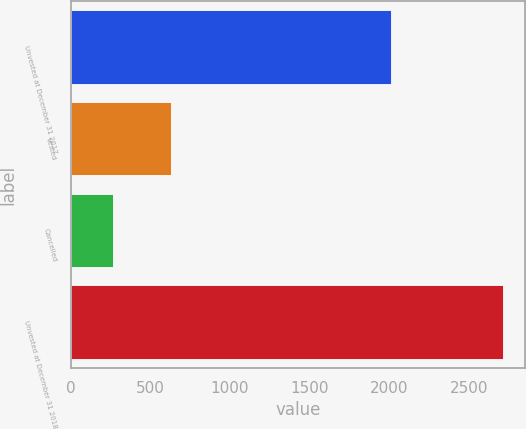<chart> <loc_0><loc_0><loc_500><loc_500><bar_chart><fcel>Unvested at December 31 2017<fcel>Vested<fcel>Cancelled<fcel>Unvested at December 31 2018<nl><fcel>2011<fcel>629<fcel>265<fcel>2717<nl></chart> 